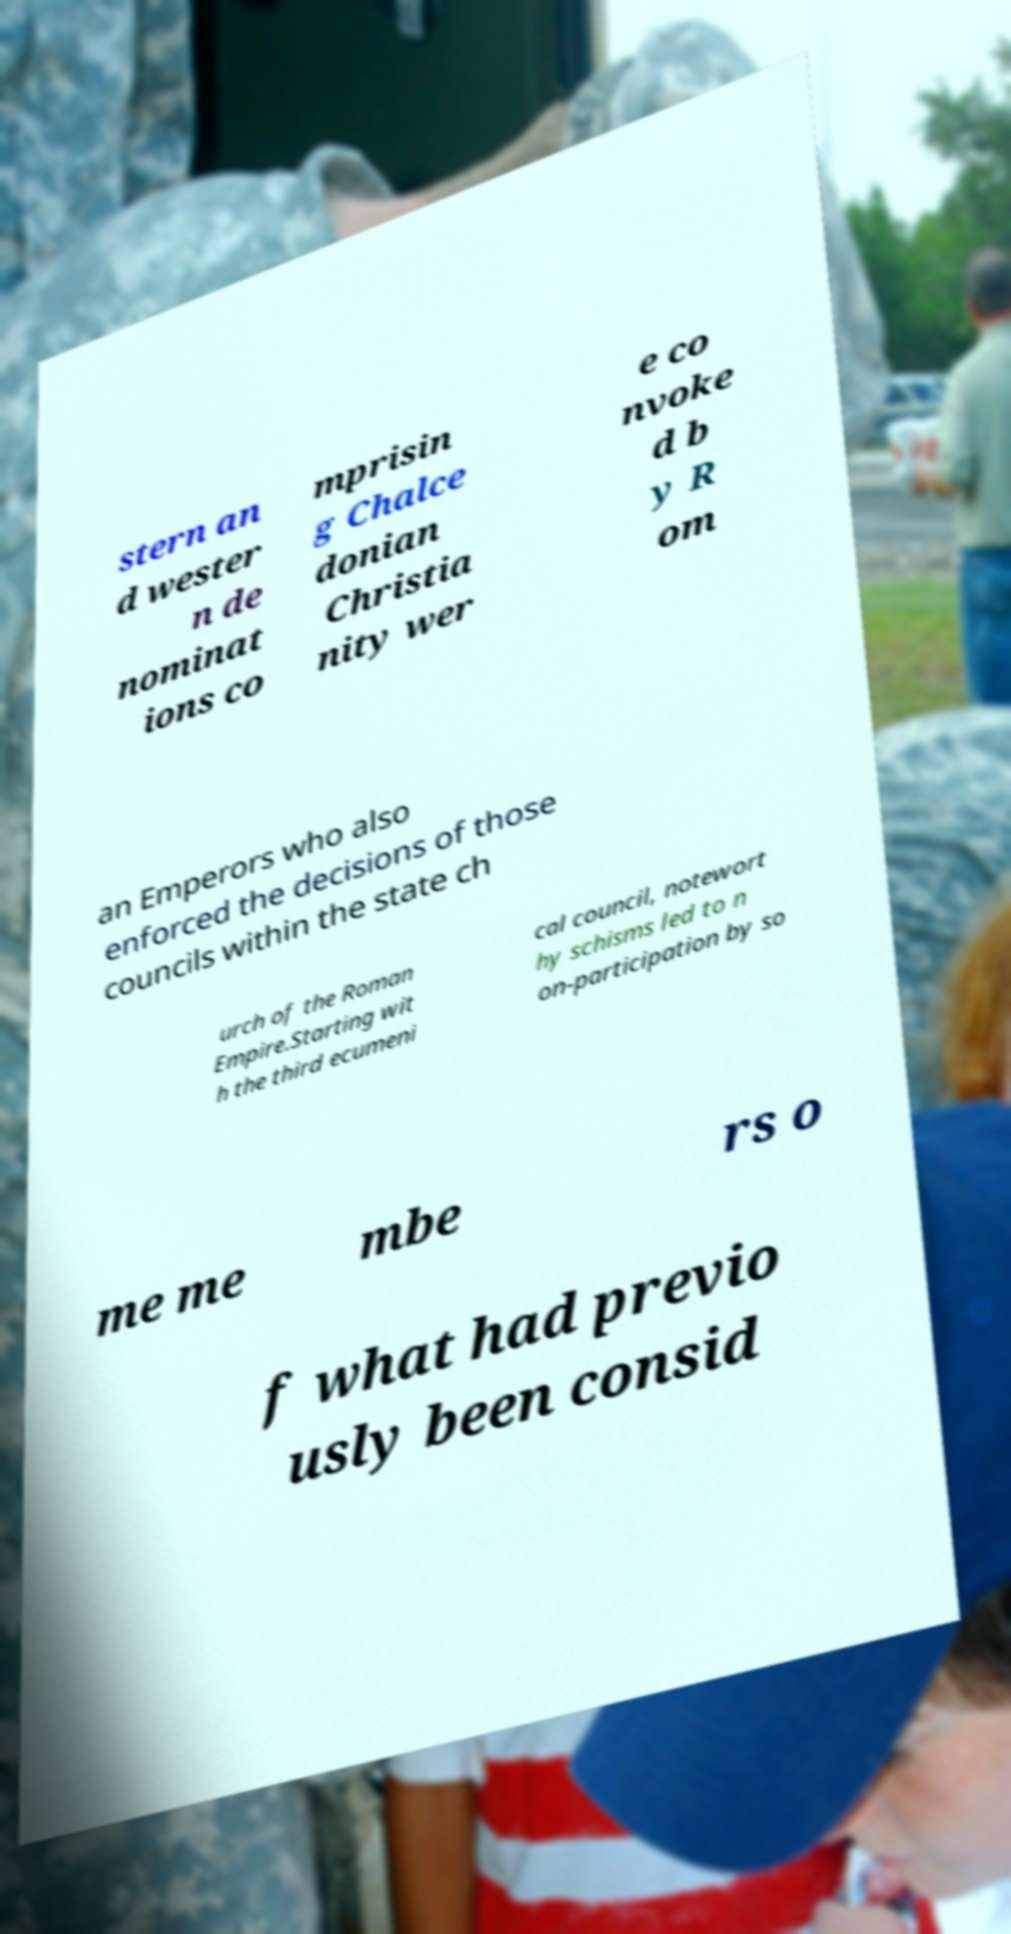Can you read and provide the text displayed in the image?This photo seems to have some interesting text. Can you extract and type it out for me? stern an d wester n de nominat ions co mprisin g Chalce donian Christia nity wer e co nvoke d b y R om an Emperors who also enforced the decisions of those councils within the state ch urch of the Roman Empire.Starting wit h the third ecumeni cal council, notewort hy schisms led to n on-participation by so me me mbe rs o f what had previo usly been consid 